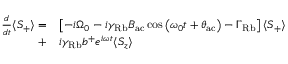<formula> <loc_0><loc_0><loc_500><loc_500>\begin{array} { r l } { \frac { d } { d t } \langle S _ { + } \rangle = } & { \left [ - i \Omega _ { 0 } - i \gamma _ { R b } B _ { a c } \cos \left ( { \omega _ { 0 } t + \theta _ { a c } } \right ) - \Gamma _ { R b } \right ] \langle S _ { + } \rangle } \\ { + } & { i \gamma _ { R b } b ^ { + } e ^ { i \omega t } \langle S _ { z } \rangle } \end{array}</formula> 